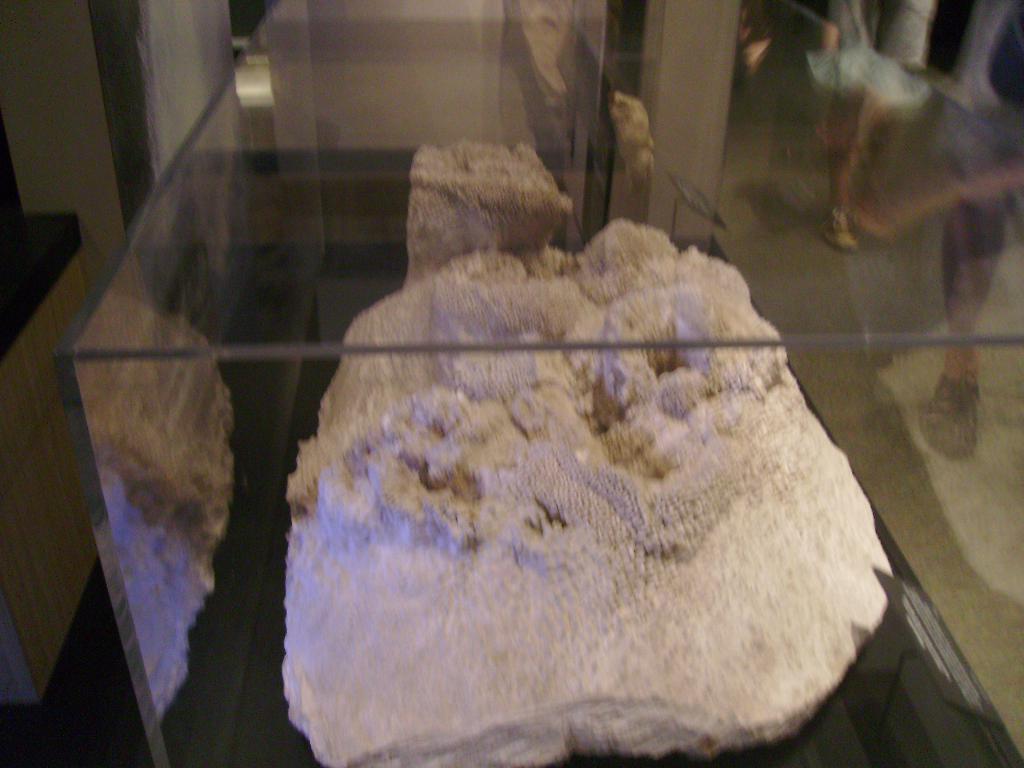Please provide a concise description of this image. In this picture I can see a rock in a glass box, there is a reflection of legs of the people on the transparent glass. 